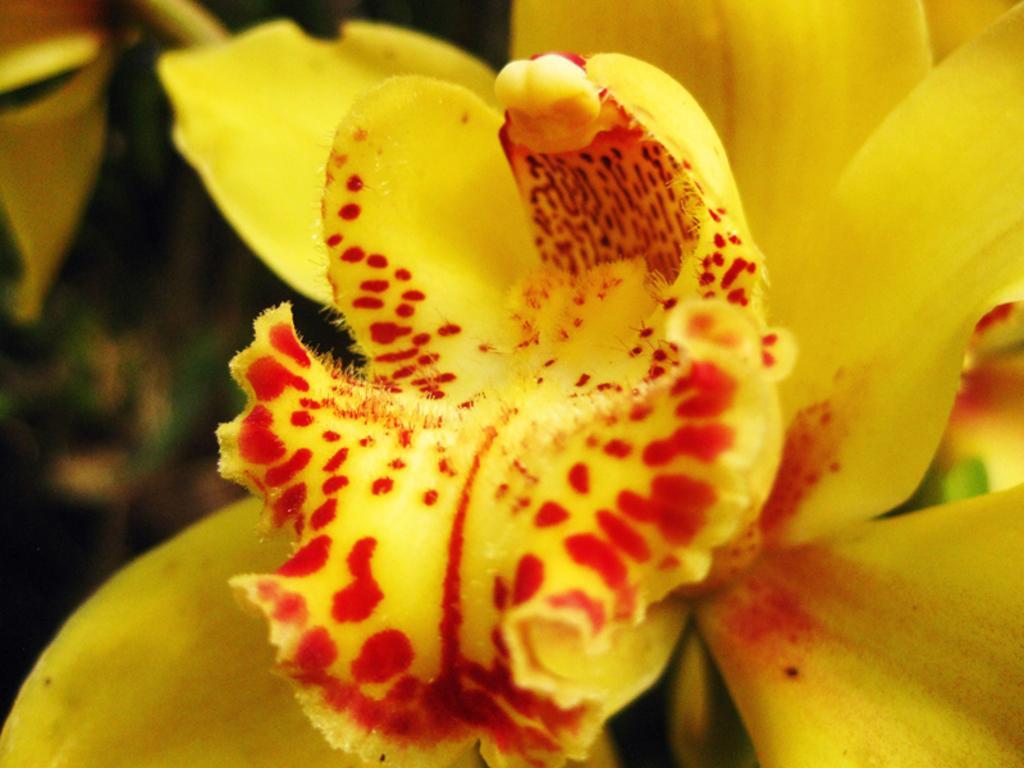How would you summarize this image in a sentence or two? In this image we can see a flower. In the background of the image there is a blur background. 